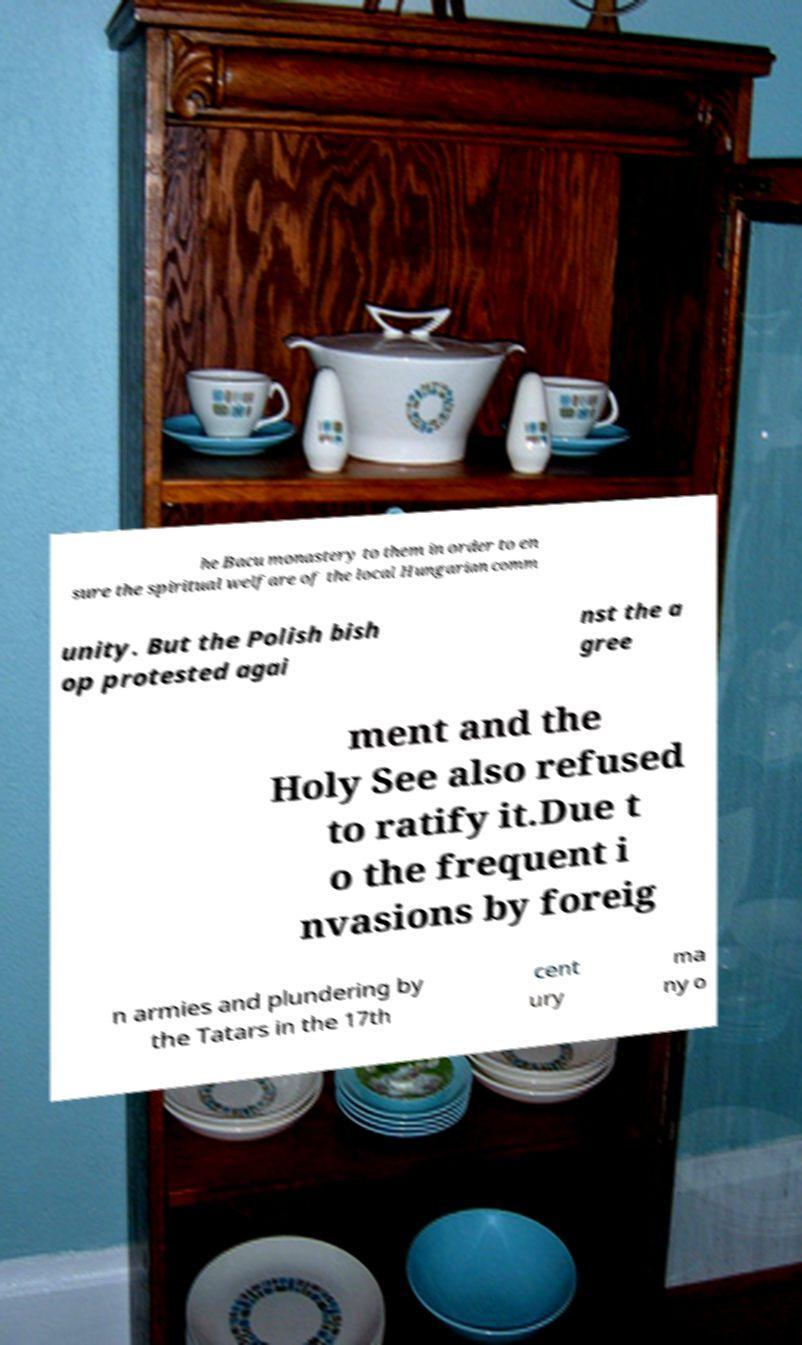Please identify and transcribe the text found in this image. he Bacu monastery to them in order to en sure the spiritual welfare of the local Hungarian comm unity. But the Polish bish op protested agai nst the a gree ment and the Holy See also refused to ratify it.Due t o the frequent i nvasions by foreig n armies and plundering by the Tatars in the 17th cent ury ma ny o 